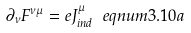<formula> <loc_0><loc_0><loc_500><loc_500>\partial _ { \nu } F ^ { \nu \mu } = e J _ { i n d } ^ { \mu } \ e q n u m { 3 . 1 0 a }</formula> 